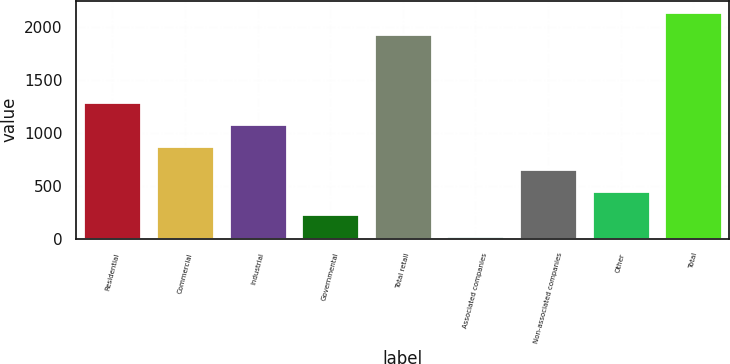Convert chart. <chart><loc_0><loc_0><loc_500><loc_500><bar_chart><fcel>Residential<fcel>Commercial<fcel>Industrial<fcel>Governmental<fcel>Total retail<fcel>Associated companies<fcel>Non-associated companies<fcel>Other<fcel>Total<nl><fcel>1296.4<fcel>873.6<fcel>1085<fcel>239.4<fcel>1931<fcel>28<fcel>662.2<fcel>450.8<fcel>2142.4<nl></chart> 